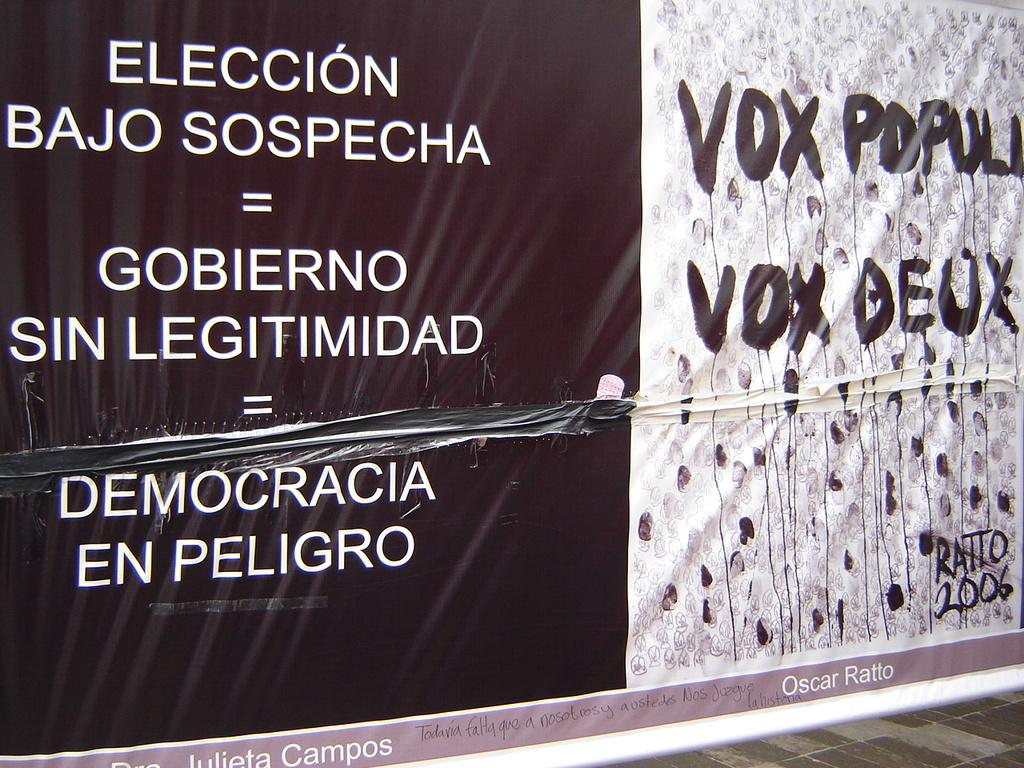<image>
Render a clear and concise summary of the photo. a black and white sign written in spanish with the name oscar ratto written on the bottom right 